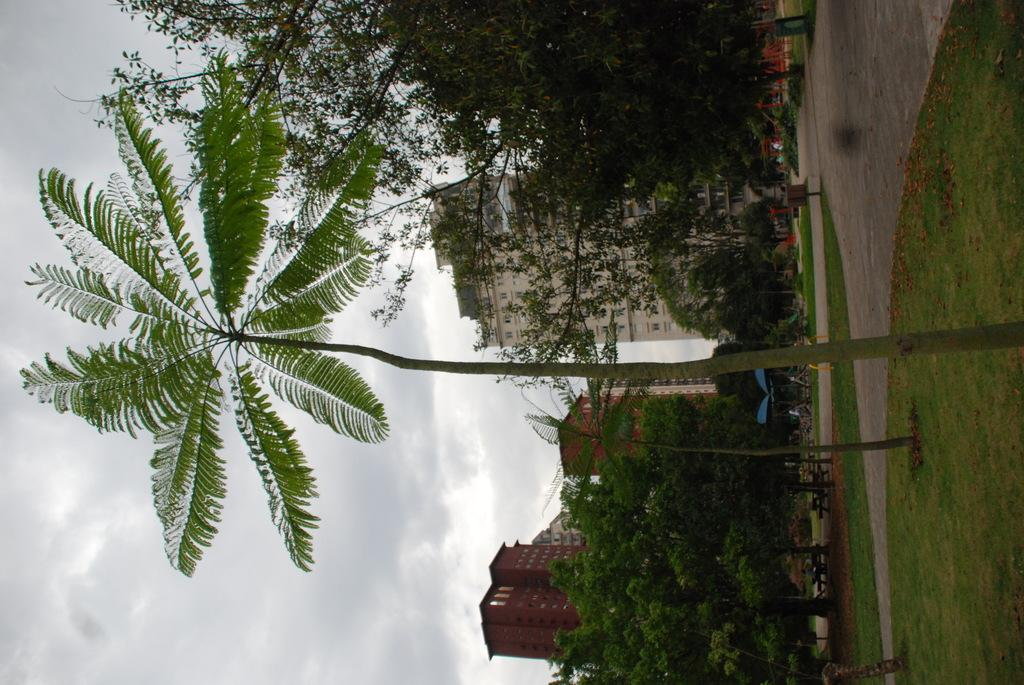What type of surface can be seen in the image? The ground is visible in the image. What type of vegetation is present in the image? There is grass and green trees in the image. What type of seating is available in the image? There are benches in the image. What type of structures can be seen in the image? There are buildings in the image. What is visible in the background of the image? The sky is visible in the background of the image. What type of cloud is present in the image? There is no cloud present in the image; the sky is visible, but no clouds are mentioned in the facts. 